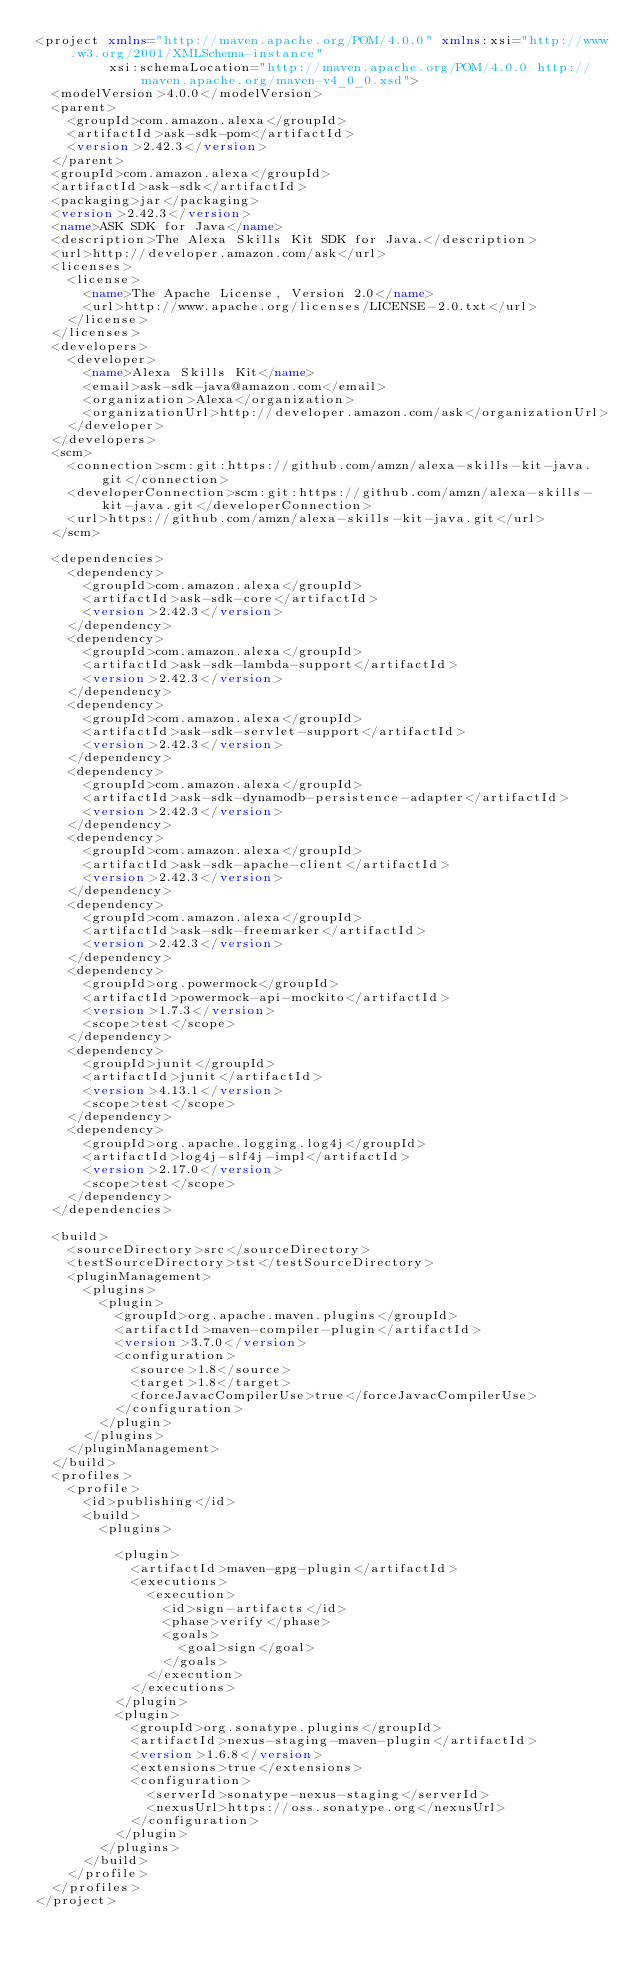Convert code to text. <code><loc_0><loc_0><loc_500><loc_500><_XML_><project xmlns="http://maven.apache.org/POM/4.0.0" xmlns:xsi="http://www.w3.org/2001/XMLSchema-instance"
         xsi:schemaLocation="http://maven.apache.org/POM/4.0.0 http://maven.apache.org/maven-v4_0_0.xsd">
  <modelVersion>4.0.0</modelVersion>
  <parent>
    <groupId>com.amazon.alexa</groupId>
    <artifactId>ask-sdk-pom</artifactId>
    <version>2.42.3</version>
  </parent>
  <groupId>com.amazon.alexa</groupId>
  <artifactId>ask-sdk</artifactId>
  <packaging>jar</packaging>
  <version>2.42.3</version>
  <name>ASK SDK for Java</name>
  <description>The Alexa Skills Kit SDK for Java.</description>
  <url>http://developer.amazon.com/ask</url>
  <licenses>
    <license>
      <name>The Apache License, Version 2.0</name>
      <url>http://www.apache.org/licenses/LICENSE-2.0.txt</url>
    </license>
  </licenses>
  <developers>
    <developer>
      <name>Alexa Skills Kit</name>
      <email>ask-sdk-java@amazon.com</email>
      <organization>Alexa</organization>
      <organizationUrl>http://developer.amazon.com/ask</organizationUrl>
    </developer>
  </developers>
  <scm>
    <connection>scm:git:https://github.com/amzn/alexa-skills-kit-java.git</connection>
    <developerConnection>scm:git:https://github.com/amzn/alexa-skills-kit-java.git</developerConnection>
    <url>https://github.com/amzn/alexa-skills-kit-java.git</url>
  </scm>

  <dependencies>
    <dependency>
      <groupId>com.amazon.alexa</groupId>
      <artifactId>ask-sdk-core</artifactId>
      <version>2.42.3</version>
    </dependency>
    <dependency>
      <groupId>com.amazon.alexa</groupId>
      <artifactId>ask-sdk-lambda-support</artifactId>
      <version>2.42.3</version>
    </dependency>
    <dependency>
      <groupId>com.amazon.alexa</groupId>
      <artifactId>ask-sdk-servlet-support</artifactId>
      <version>2.42.3</version>
    </dependency>
    <dependency>
      <groupId>com.amazon.alexa</groupId>
      <artifactId>ask-sdk-dynamodb-persistence-adapter</artifactId>
      <version>2.42.3</version>
    </dependency>
    <dependency>
      <groupId>com.amazon.alexa</groupId>
      <artifactId>ask-sdk-apache-client</artifactId>
      <version>2.42.3</version>
    </dependency>
    <dependency>
      <groupId>com.amazon.alexa</groupId>
      <artifactId>ask-sdk-freemarker</artifactId>
      <version>2.42.3</version>
    </dependency>
    <dependency>
      <groupId>org.powermock</groupId>
      <artifactId>powermock-api-mockito</artifactId>
      <version>1.7.3</version>
      <scope>test</scope>
    </dependency>
    <dependency>
      <groupId>junit</groupId>
      <artifactId>junit</artifactId>
      <version>4.13.1</version>
      <scope>test</scope>
    </dependency>
    <dependency>
      <groupId>org.apache.logging.log4j</groupId>
      <artifactId>log4j-slf4j-impl</artifactId>
      <version>2.17.0</version>
      <scope>test</scope>
    </dependency>
  </dependencies>

  <build>
    <sourceDirectory>src</sourceDirectory>
    <testSourceDirectory>tst</testSourceDirectory>
    <pluginManagement>
      <plugins>
        <plugin>
          <groupId>org.apache.maven.plugins</groupId>
          <artifactId>maven-compiler-plugin</artifactId>
          <version>3.7.0</version>
          <configuration>
            <source>1.8</source>
            <target>1.8</target>
            <forceJavacCompilerUse>true</forceJavacCompilerUse>
          </configuration>
        </plugin>
      </plugins>
    </pluginManagement>
  </build>
  <profiles>
    <profile>
      <id>publishing</id>
      <build>
        <plugins>

          <plugin>
            <artifactId>maven-gpg-plugin</artifactId>
            <executions>
              <execution>
                <id>sign-artifacts</id>
                <phase>verify</phase>
                <goals>
                  <goal>sign</goal>
                </goals>
              </execution>
            </executions>
          </plugin>
          <plugin>
            <groupId>org.sonatype.plugins</groupId>
            <artifactId>nexus-staging-maven-plugin</artifactId>
            <version>1.6.8</version>
            <extensions>true</extensions>
            <configuration>
              <serverId>sonatype-nexus-staging</serverId>
              <nexusUrl>https://oss.sonatype.org</nexusUrl>
            </configuration>
          </plugin>
        </plugins>
      </build>
    </profile>
  </profiles>
</project>
</code> 